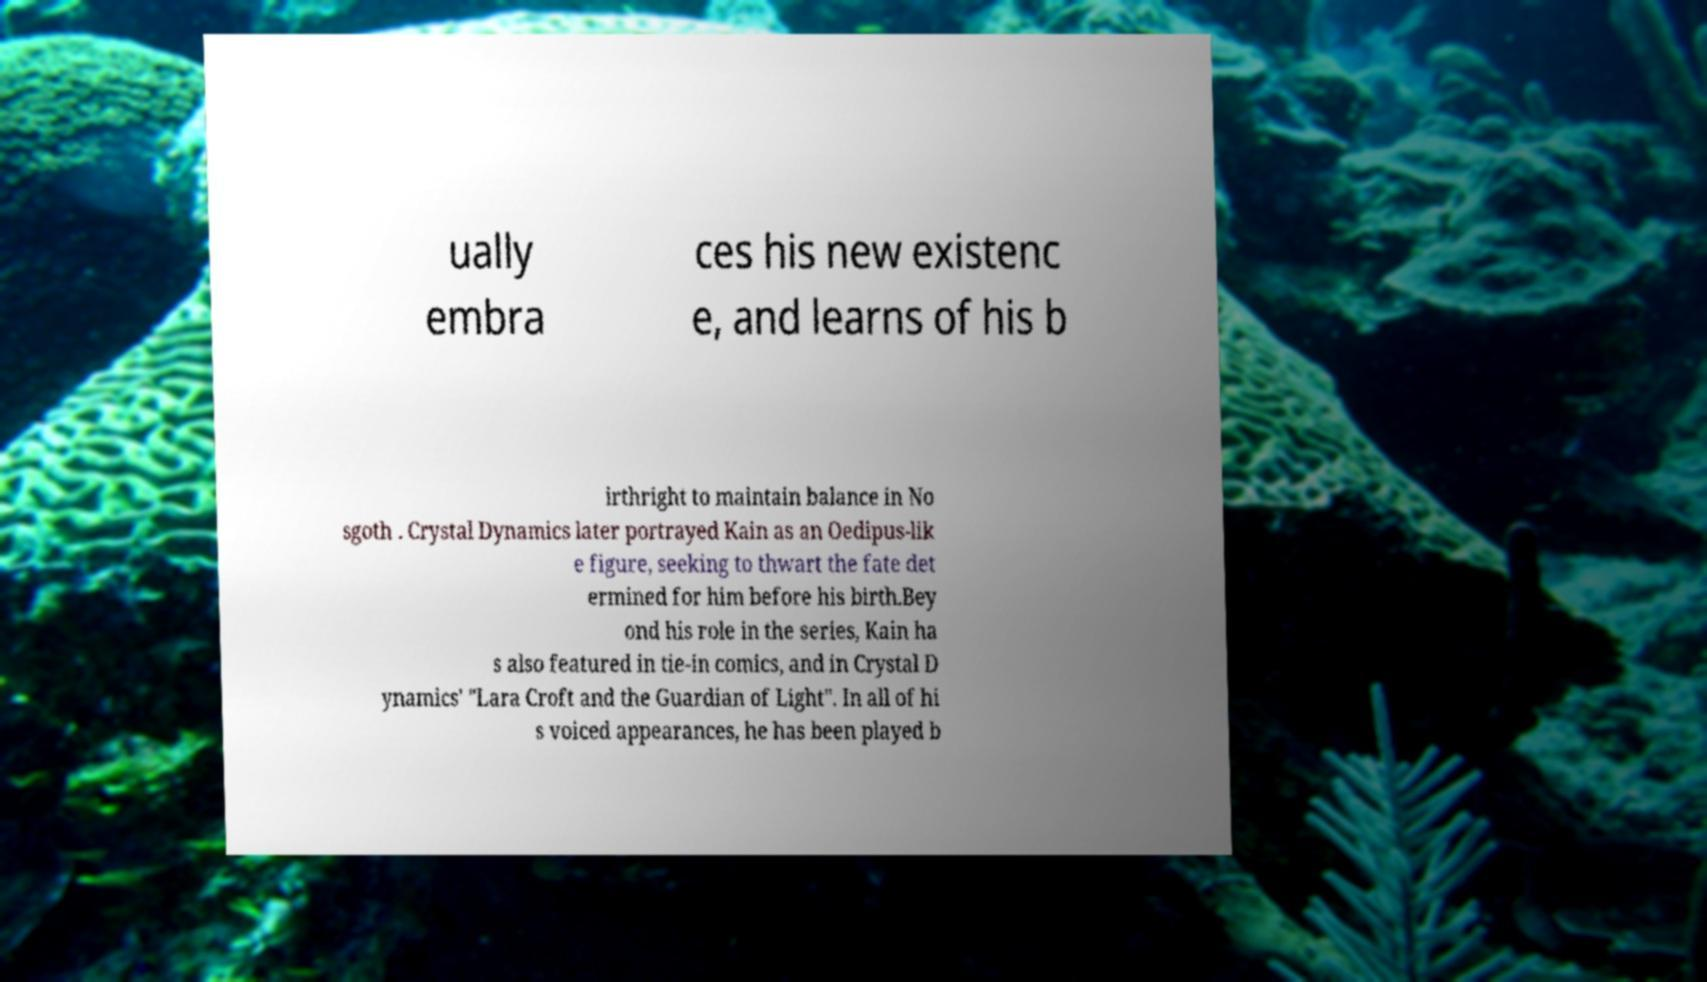Could you assist in decoding the text presented in this image and type it out clearly? ually embra ces his new existenc e, and learns of his b irthright to maintain balance in No sgoth . Crystal Dynamics later portrayed Kain as an Oedipus-lik e figure, seeking to thwart the fate det ermined for him before his birth.Bey ond his role in the series, Kain ha s also featured in tie-in comics, and in Crystal D ynamics' "Lara Croft and the Guardian of Light". In all of hi s voiced appearances, he has been played b 